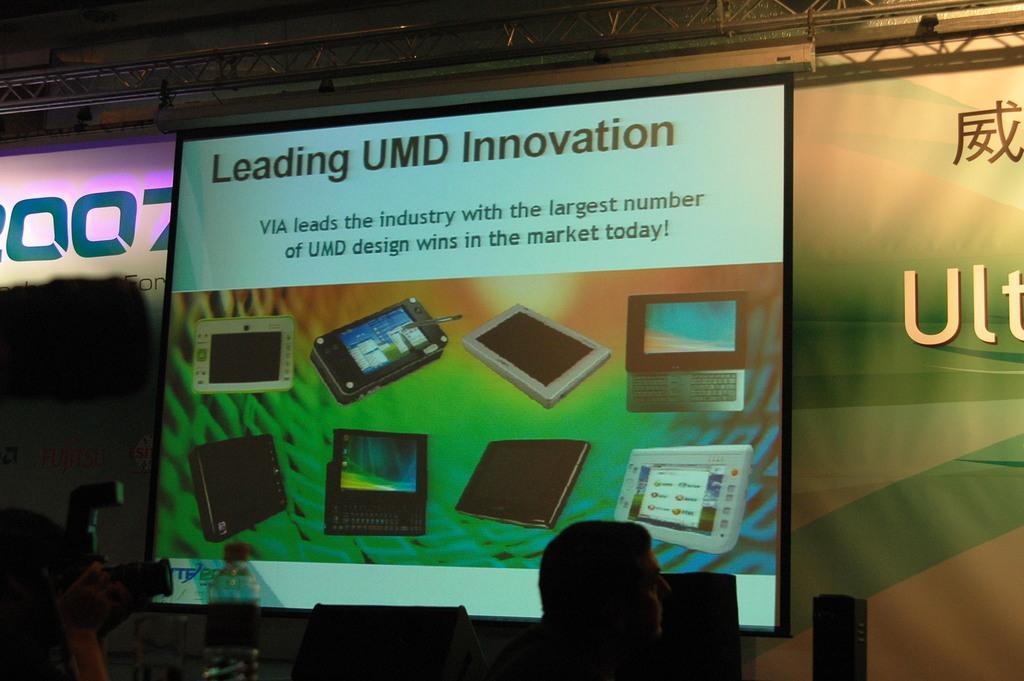Can you describe this image briefly? In this image we can see the screen with text and images and at the back there is a banner with text and at the top we can see the rods. In front of the screen we can see there are two persons holding a camera and there are boxes. 